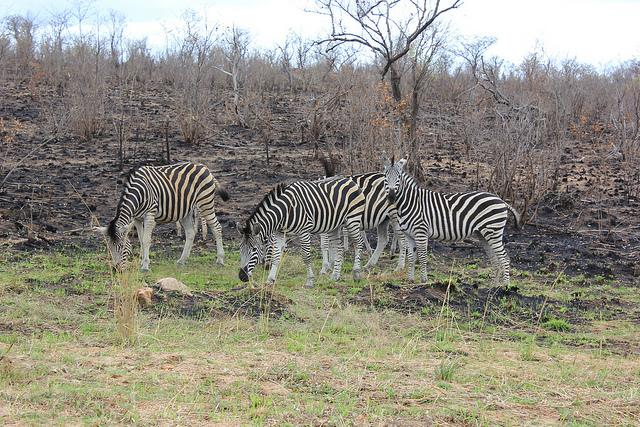What are these animals known for? Please explain your reasoning. stripes. These are zebras and they have vertical lines in black and white. 